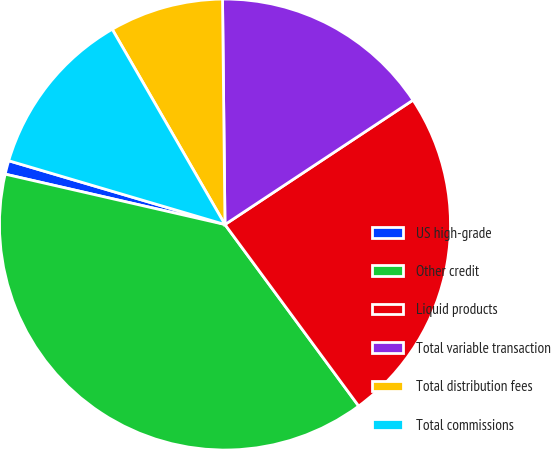<chart> <loc_0><loc_0><loc_500><loc_500><pie_chart><fcel>US high-grade<fcel>Other credit<fcel>Liquid products<fcel>Total variable transaction<fcel>Total distribution fees<fcel>Total commissions<nl><fcel>0.98%<fcel>38.69%<fcel>24.2%<fcel>15.87%<fcel>8.16%<fcel>12.1%<nl></chart> 